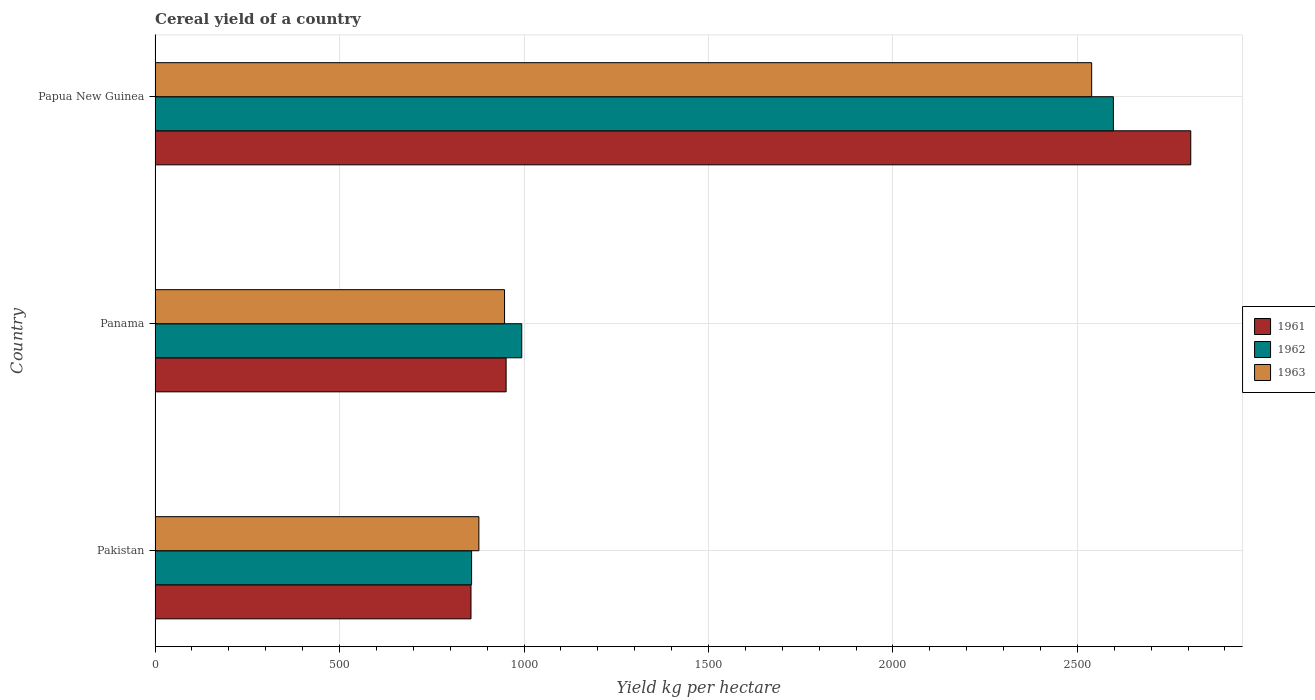How many groups of bars are there?
Provide a succinct answer. 3. Are the number of bars per tick equal to the number of legend labels?
Offer a very short reply. Yes. Are the number of bars on each tick of the Y-axis equal?
Give a very brief answer. Yes. How many bars are there on the 1st tick from the bottom?
Offer a very short reply. 3. In how many cases, is the number of bars for a given country not equal to the number of legend labels?
Offer a terse response. 0. What is the total cereal yield in 1962 in Panama?
Provide a short and direct response. 993.92. Across all countries, what is the maximum total cereal yield in 1962?
Give a very brief answer. 2597.53. Across all countries, what is the minimum total cereal yield in 1963?
Keep it short and to the point. 877.71. In which country was the total cereal yield in 1963 maximum?
Offer a very short reply. Papua New Guinea. In which country was the total cereal yield in 1963 minimum?
Your answer should be compact. Pakistan. What is the total total cereal yield in 1961 in the graph?
Provide a succinct answer. 4615.18. What is the difference between the total cereal yield in 1962 in Panama and that in Papua New Guinea?
Your answer should be very brief. -1603.6. What is the difference between the total cereal yield in 1963 in Panama and the total cereal yield in 1961 in Papua New Guinea?
Ensure brevity in your answer.  -1859.98. What is the average total cereal yield in 1961 per country?
Give a very brief answer. 1538.39. What is the difference between the total cereal yield in 1961 and total cereal yield in 1963 in Pakistan?
Offer a very short reply. -21.36. In how many countries, is the total cereal yield in 1961 greater than 2000 kg per hectare?
Provide a short and direct response. 1. What is the ratio of the total cereal yield in 1963 in Pakistan to that in Panama?
Give a very brief answer. 0.93. Is the total cereal yield in 1962 in Pakistan less than that in Panama?
Make the answer very short. Yes. Is the difference between the total cereal yield in 1961 in Pakistan and Panama greater than the difference between the total cereal yield in 1963 in Pakistan and Panama?
Your response must be concise. No. What is the difference between the highest and the second highest total cereal yield in 1961?
Your answer should be very brief. 1855.74. What is the difference between the highest and the lowest total cereal yield in 1962?
Your answer should be compact. 1739.57. In how many countries, is the total cereal yield in 1962 greater than the average total cereal yield in 1962 taken over all countries?
Ensure brevity in your answer.  1. What does the 3rd bar from the top in Papua New Guinea represents?
Your answer should be compact. 1961. Is it the case that in every country, the sum of the total cereal yield in 1962 and total cereal yield in 1961 is greater than the total cereal yield in 1963?
Keep it short and to the point. Yes. How many bars are there?
Your answer should be compact. 9. Are all the bars in the graph horizontal?
Offer a very short reply. Yes. How many countries are there in the graph?
Provide a short and direct response. 3. What is the difference between two consecutive major ticks on the X-axis?
Your answer should be very brief. 500. Where does the legend appear in the graph?
Keep it short and to the point. Center right. How many legend labels are there?
Your answer should be very brief. 3. How are the legend labels stacked?
Your answer should be compact. Vertical. What is the title of the graph?
Offer a very short reply. Cereal yield of a country. What is the label or title of the X-axis?
Provide a short and direct response. Yield kg per hectare. What is the label or title of the Y-axis?
Make the answer very short. Country. What is the Yield kg per hectare in 1961 in Pakistan?
Ensure brevity in your answer.  856.35. What is the Yield kg per hectare of 1962 in Pakistan?
Offer a very short reply. 857.96. What is the Yield kg per hectare in 1963 in Pakistan?
Provide a short and direct response. 877.71. What is the Yield kg per hectare in 1961 in Panama?
Your answer should be compact. 951.54. What is the Yield kg per hectare in 1962 in Panama?
Your answer should be compact. 993.92. What is the Yield kg per hectare of 1963 in Panama?
Provide a succinct answer. 947.3. What is the Yield kg per hectare of 1961 in Papua New Guinea?
Make the answer very short. 2807.28. What is the Yield kg per hectare in 1962 in Papua New Guinea?
Keep it short and to the point. 2597.53. What is the Yield kg per hectare in 1963 in Papua New Guinea?
Make the answer very short. 2538.67. Across all countries, what is the maximum Yield kg per hectare in 1961?
Your answer should be compact. 2807.28. Across all countries, what is the maximum Yield kg per hectare of 1962?
Make the answer very short. 2597.53. Across all countries, what is the maximum Yield kg per hectare in 1963?
Your response must be concise. 2538.67. Across all countries, what is the minimum Yield kg per hectare of 1961?
Your answer should be very brief. 856.35. Across all countries, what is the minimum Yield kg per hectare in 1962?
Provide a succinct answer. 857.96. Across all countries, what is the minimum Yield kg per hectare of 1963?
Your answer should be very brief. 877.71. What is the total Yield kg per hectare in 1961 in the graph?
Keep it short and to the point. 4615.18. What is the total Yield kg per hectare of 1962 in the graph?
Ensure brevity in your answer.  4449.41. What is the total Yield kg per hectare of 1963 in the graph?
Keep it short and to the point. 4363.68. What is the difference between the Yield kg per hectare of 1961 in Pakistan and that in Panama?
Offer a terse response. -95.19. What is the difference between the Yield kg per hectare of 1962 in Pakistan and that in Panama?
Provide a short and direct response. -135.97. What is the difference between the Yield kg per hectare in 1963 in Pakistan and that in Panama?
Provide a short and direct response. -69.59. What is the difference between the Yield kg per hectare of 1961 in Pakistan and that in Papua New Guinea?
Offer a terse response. -1950.93. What is the difference between the Yield kg per hectare of 1962 in Pakistan and that in Papua New Guinea?
Provide a succinct answer. -1739.57. What is the difference between the Yield kg per hectare of 1963 in Pakistan and that in Papua New Guinea?
Offer a very short reply. -1660.96. What is the difference between the Yield kg per hectare in 1961 in Panama and that in Papua New Guinea?
Your response must be concise. -1855.74. What is the difference between the Yield kg per hectare of 1962 in Panama and that in Papua New Guinea?
Ensure brevity in your answer.  -1603.6. What is the difference between the Yield kg per hectare in 1963 in Panama and that in Papua New Guinea?
Make the answer very short. -1591.37. What is the difference between the Yield kg per hectare in 1961 in Pakistan and the Yield kg per hectare in 1962 in Panama?
Give a very brief answer. -137.57. What is the difference between the Yield kg per hectare in 1961 in Pakistan and the Yield kg per hectare in 1963 in Panama?
Ensure brevity in your answer.  -90.95. What is the difference between the Yield kg per hectare of 1962 in Pakistan and the Yield kg per hectare of 1963 in Panama?
Your response must be concise. -89.34. What is the difference between the Yield kg per hectare in 1961 in Pakistan and the Yield kg per hectare in 1962 in Papua New Guinea?
Ensure brevity in your answer.  -1741.18. What is the difference between the Yield kg per hectare of 1961 in Pakistan and the Yield kg per hectare of 1963 in Papua New Guinea?
Offer a very short reply. -1682.32. What is the difference between the Yield kg per hectare in 1962 in Pakistan and the Yield kg per hectare in 1963 in Papua New Guinea?
Your response must be concise. -1680.71. What is the difference between the Yield kg per hectare in 1961 in Panama and the Yield kg per hectare in 1962 in Papua New Guinea?
Provide a succinct answer. -1645.98. What is the difference between the Yield kg per hectare of 1961 in Panama and the Yield kg per hectare of 1963 in Papua New Guinea?
Your response must be concise. -1587.12. What is the difference between the Yield kg per hectare in 1962 in Panama and the Yield kg per hectare in 1963 in Papua New Guinea?
Provide a short and direct response. -1544.75. What is the average Yield kg per hectare of 1961 per country?
Provide a succinct answer. 1538.39. What is the average Yield kg per hectare of 1962 per country?
Keep it short and to the point. 1483.14. What is the average Yield kg per hectare in 1963 per country?
Ensure brevity in your answer.  1454.56. What is the difference between the Yield kg per hectare in 1961 and Yield kg per hectare in 1962 in Pakistan?
Your answer should be compact. -1.61. What is the difference between the Yield kg per hectare in 1961 and Yield kg per hectare in 1963 in Pakistan?
Give a very brief answer. -21.36. What is the difference between the Yield kg per hectare in 1962 and Yield kg per hectare in 1963 in Pakistan?
Ensure brevity in your answer.  -19.76. What is the difference between the Yield kg per hectare in 1961 and Yield kg per hectare in 1962 in Panama?
Offer a very short reply. -42.38. What is the difference between the Yield kg per hectare of 1961 and Yield kg per hectare of 1963 in Panama?
Offer a very short reply. 4.25. What is the difference between the Yield kg per hectare of 1962 and Yield kg per hectare of 1963 in Panama?
Your response must be concise. 46.62. What is the difference between the Yield kg per hectare in 1961 and Yield kg per hectare in 1962 in Papua New Guinea?
Make the answer very short. 209.76. What is the difference between the Yield kg per hectare of 1961 and Yield kg per hectare of 1963 in Papua New Guinea?
Your answer should be compact. 268.61. What is the difference between the Yield kg per hectare of 1962 and Yield kg per hectare of 1963 in Papua New Guinea?
Your answer should be very brief. 58.86. What is the ratio of the Yield kg per hectare in 1962 in Pakistan to that in Panama?
Make the answer very short. 0.86. What is the ratio of the Yield kg per hectare of 1963 in Pakistan to that in Panama?
Offer a very short reply. 0.93. What is the ratio of the Yield kg per hectare in 1961 in Pakistan to that in Papua New Guinea?
Give a very brief answer. 0.3. What is the ratio of the Yield kg per hectare in 1962 in Pakistan to that in Papua New Guinea?
Offer a very short reply. 0.33. What is the ratio of the Yield kg per hectare of 1963 in Pakistan to that in Papua New Guinea?
Ensure brevity in your answer.  0.35. What is the ratio of the Yield kg per hectare in 1961 in Panama to that in Papua New Guinea?
Your answer should be very brief. 0.34. What is the ratio of the Yield kg per hectare in 1962 in Panama to that in Papua New Guinea?
Your answer should be compact. 0.38. What is the ratio of the Yield kg per hectare of 1963 in Panama to that in Papua New Guinea?
Your response must be concise. 0.37. What is the difference between the highest and the second highest Yield kg per hectare in 1961?
Ensure brevity in your answer.  1855.74. What is the difference between the highest and the second highest Yield kg per hectare in 1962?
Provide a short and direct response. 1603.6. What is the difference between the highest and the second highest Yield kg per hectare in 1963?
Provide a short and direct response. 1591.37. What is the difference between the highest and the lowest Yield kg per hectare in 1961?
Your answer should be compact. 1950.93. What is the difference between the highest and the lowest Yield kg per hectare in 1962?
Offer a very short reply. 1739.57. What is the difference between the highest and the lowest Yield kg per hectare of 1963?
Give a very brief answer. 1660.96. 